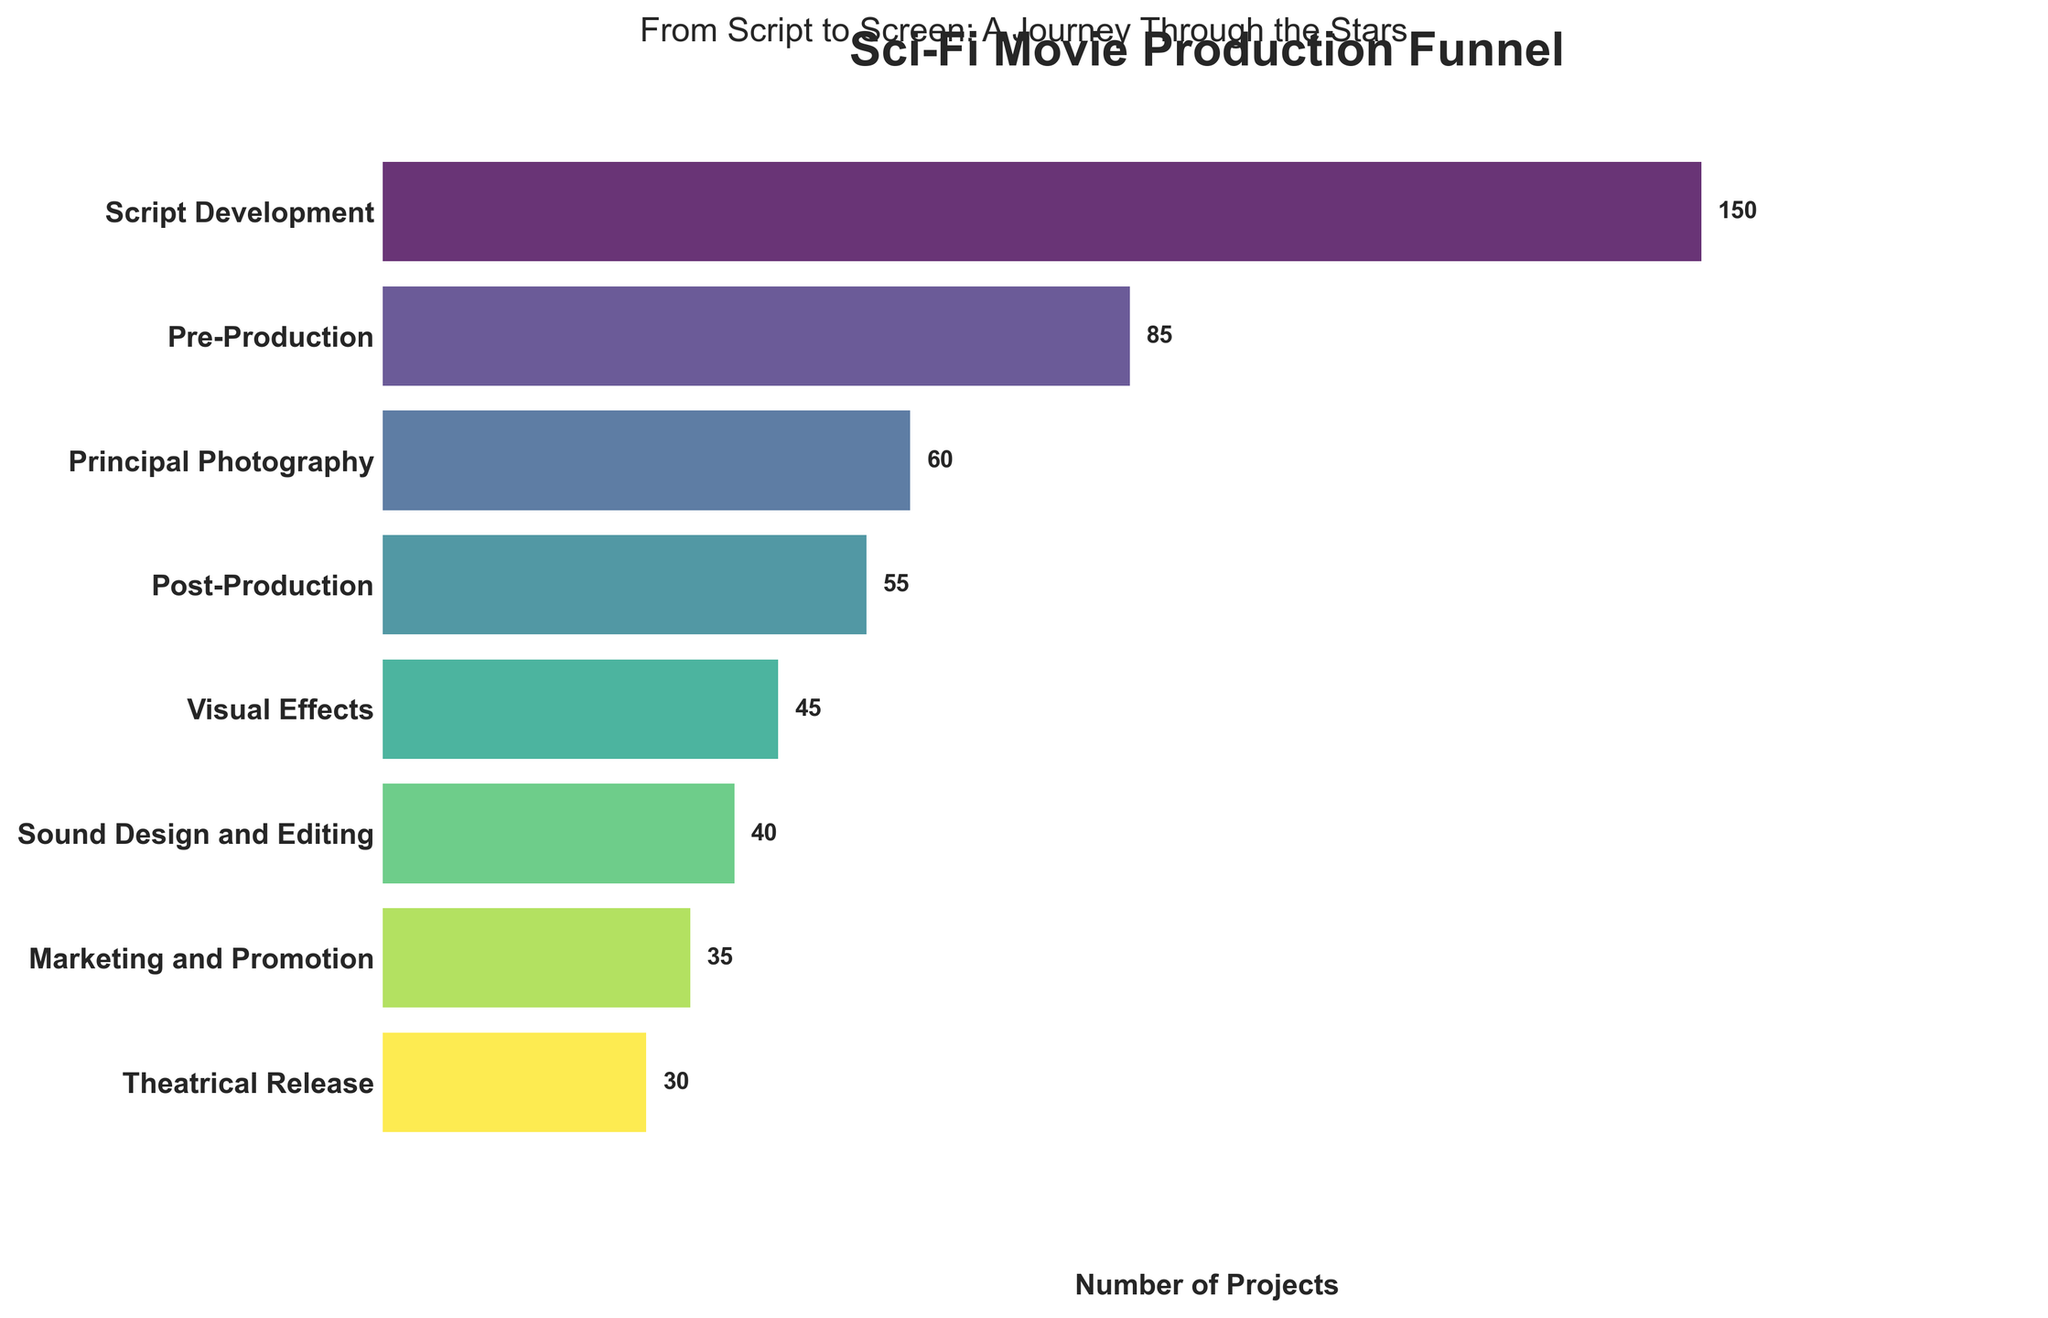what is the title of the figure? The title is found at the top of the figure and is usually bolded and centered for visibility. In this case, the title is clearly visible at the top.
Answer: Sci-Fi Movie Production Funnel What is the total number of projects from Script Development to Theatrical Release? To find the total number of projects, add all the numbers mentioned for each stage: 150 (Script Development) + 85 (Pre-Production) + 60 (Principal Photography) + 55 (Post-Production) + 45 (Visual Effects) + 40 (Sound Design and Editing) + 35 (Marketing and Promotion) + 30 (Theatrical Release) = 500
Answer: 500 How many stages are there in the figure? To determine the number of stages, count the different labels on the y-axis. Each stage corresponds to one label.
Answer: 8 Which stage has the least number of projects? The stage with the smallest bar and number label closest to zero represents the stage with the least number of projects.
Answer: Theatrical Release What is the difference in the number of projects between Script Development and Principal Photography? Subtract the number of projects in Principal Photography from Script Development: 150 (Script Development) - 60 (Principal Photography) = 90
Answer: 90 Which stage immediately follows Post-Production? The stages are listed in a sequential order from top to bottom, so the stage immediately after Post-Production is the next stage listed directly below it.
Answer: Visual Effects By how many projects does the number of projects decrease from Pre-Production to Marketing and Promotion? Subtract the number of projects in Marketing and Promotion from Pre-Production: 85 (Pre-Production) - 35 (Marketing and Promotion) = 50
Answer: 50 Which stage shows a reduction of exactly 10 projects from the previous stage? Look for consecutive stages where the difference in the number of projects is 10. From Post-Production to Visual Effects, the number of projects decreases by exactly 10 (55 - 45 = 10).
Answer: Visual Effects What is the average number of projects per stage? To find the average number of projects per stage, divide the total number of projects by the number of stages: 500 (total number of projects) ÷ 8 (number of stages) = 62.5
Answer: 62.5 How does the number of projects in Sound Design and Editing compare to Visual Effects? Compare the numbers directly; Sound Design and Editing has 40 projects and Visual Effects has 45. Sound Design and Editing has fewer projects than Visual Effects.
Answer: Less 